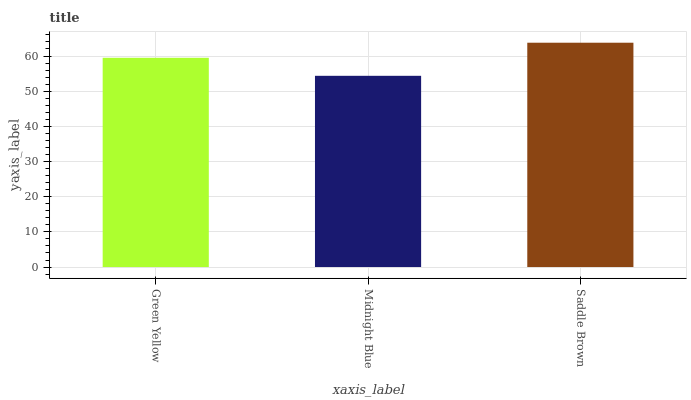Is Midnight Blue the minimum?
Answer yes or no. Yes. Is Saddle Brown the maximum?
Answer yes or no. Yes. Is Saddle Brown the minimum?
Answer yes or no. No. Is Midnight Blue the maximum?
Answer yes or no. No. Is Saddle Brown greater than Midnight Blue?
Answer yes or no. Yes. Is Midnight Blue less than Saddle Brown?
Answer yes or no. Yes. Is Midnight Blue greater than Saddle Brown?
Answer yes or no. No. Is Saddle Brown less than Midnight Blue?
Answer yes or no. No. Is Green Yellow the high median?
Answer yes or no. Yes. Is Green Yellow the low median?
Answer yes or no. Yes. Is Saddle Brown the high median?
Answer yes or no. No. Is Midnight Blue the low median?
Answer yes or no. No. 